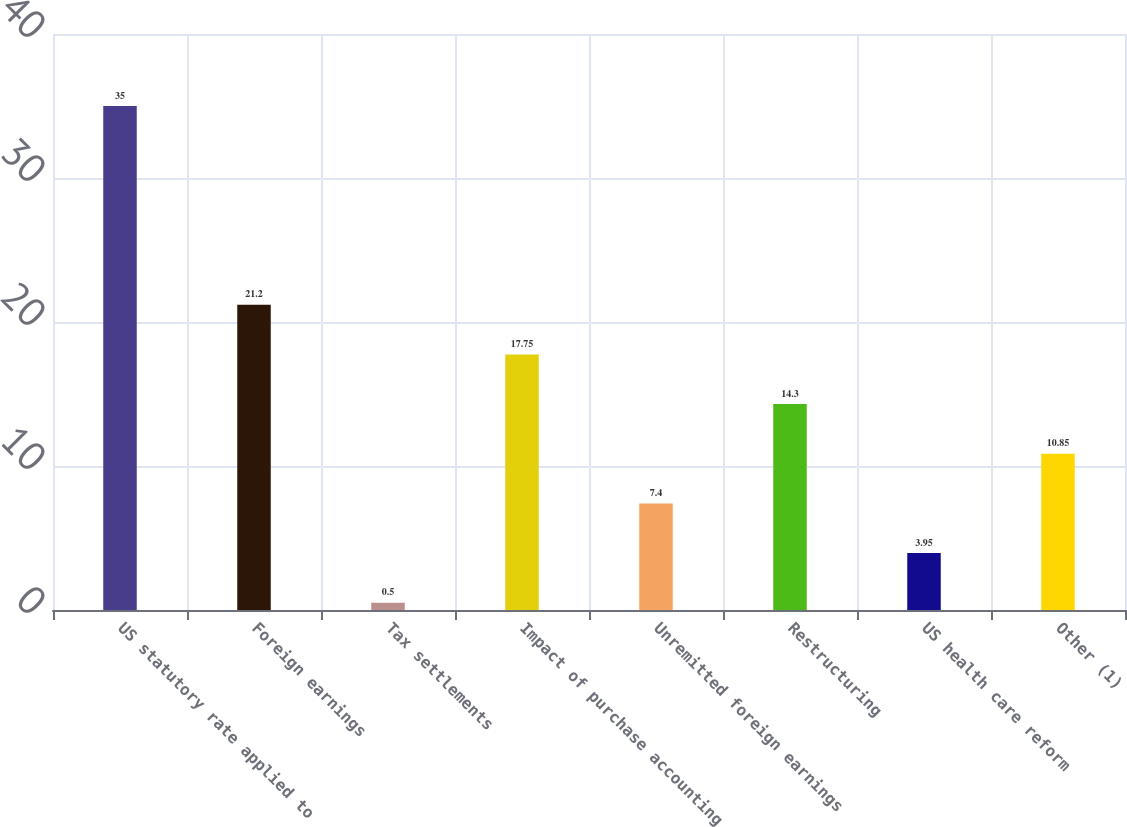Convert chart. <chart><loc_0><loc_0><loc_500><loc_500><bar_chart><fcel>US statutory rate applied to<fcel>Foreign earnings<fcel>Tax settlements<fcel>Impact of purchase accounting<fcel>Unremitted foreign earnings<fcel>Restructuring<fcel>US health care reform<fcel>Other (1)<nl><fcel>35<fcel>21.2<fcel>0.5<fcel>17.75<fcel>7.4<fcel>14.3<fcel>3.95<fcel>10.85<nl></chart> 